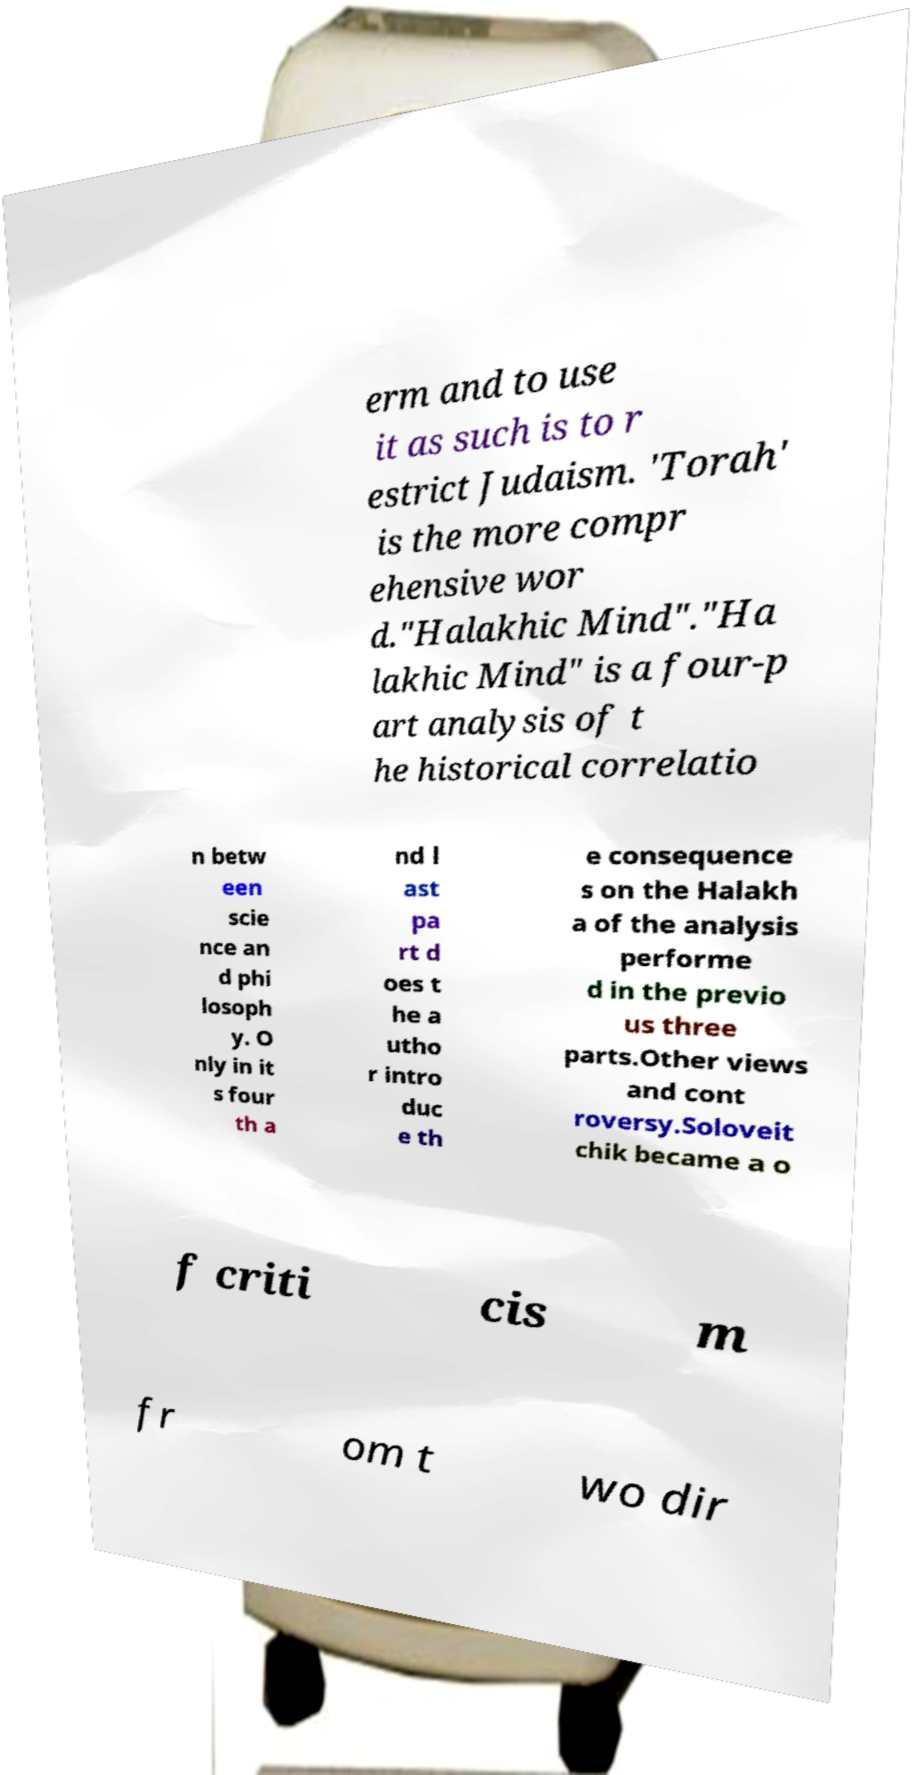Please read and relay the text visible in this image. What does it say? erm and to use it as such is to r estrict Judaism. 'Torah' is the more compr ehensive wor d."Halakhic Mind"."Ha lakhic Mind" is a four-p art analysis of t he historical correlatio n betw een scie nce an d phi losoph y. O nly in it s four th a nd l ast pa rt d oes t he a utho r intro duc e th e consequence s on the Halakh a of the analysis performe d in the previo us three parts.Other views and cont roversy.Soloveit chik became a o f criti cis m fr om t wo dir 